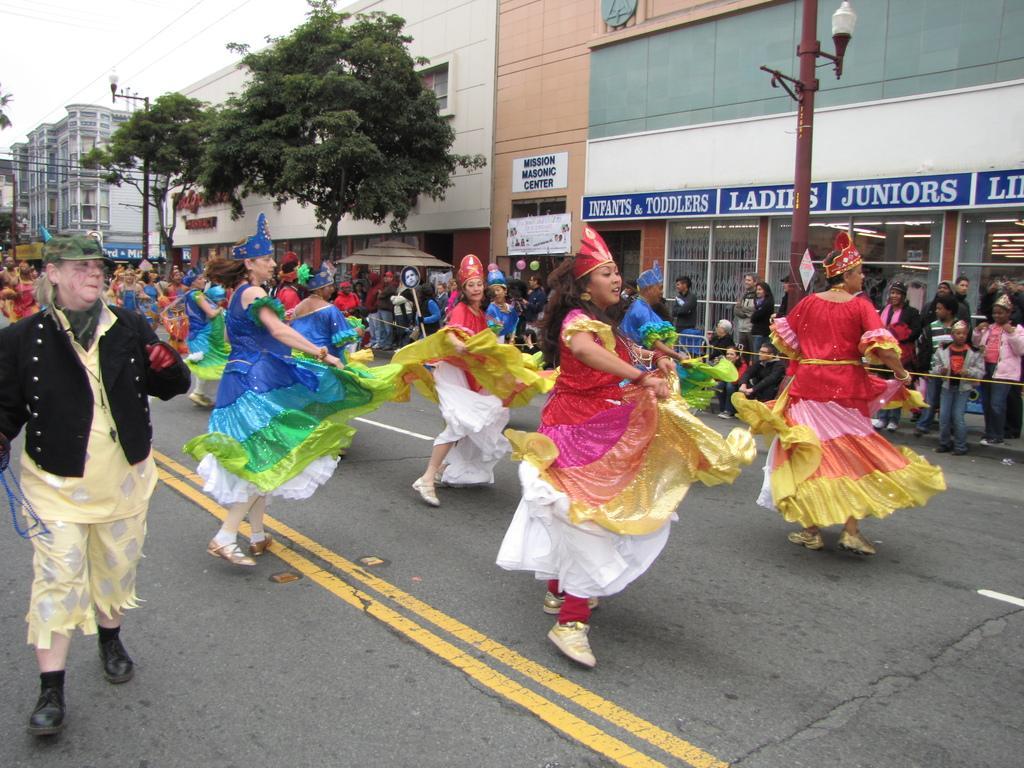Can you describe this image briefly? This picture is clicked outside. In the center we can see the group of persons dancing on the road and we can see the group of persons standing and sitting. In the background we can see the sky, cables, lamps attached to the poles and we can see the trees and buildings and we can see the text on the buildings and we can see some other objects. 